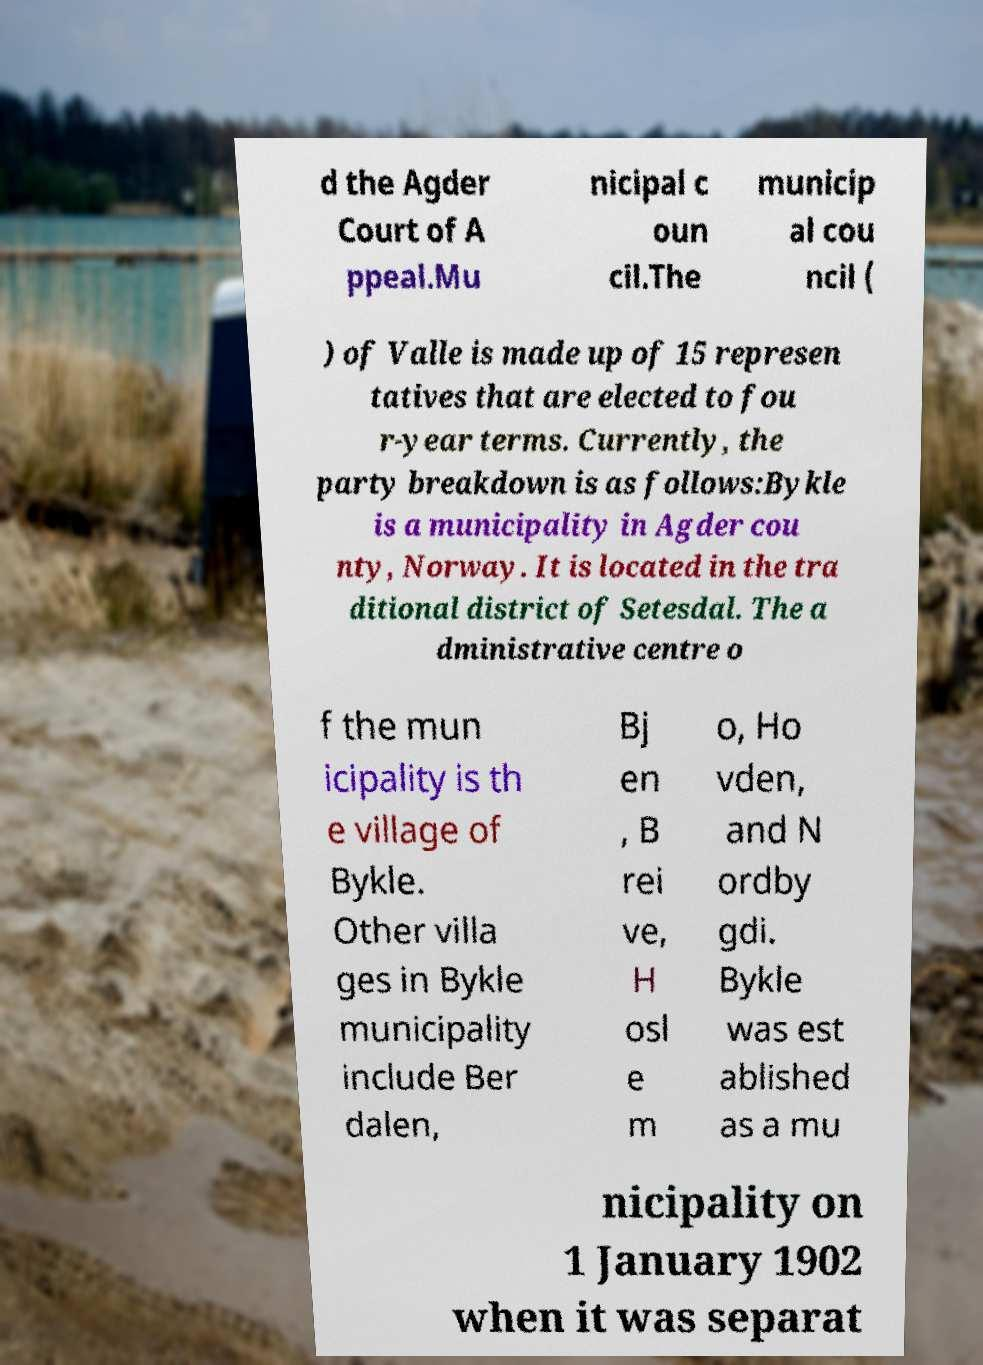For documentation purposes, I need the text within this image transcribed. Could you provide that? d the Agder Court of A ppeal.Mu nicipal c oun cil.The municip al cou ncil ( ) of Valle is made up of 15 represen tatives that are elected to fou r-year terms. Currently, the party breakdown is as follows:Bykle is a municipality in Agder cou nty, Norway. It is located in the tra ditional district of Setesdal. The a dministrative centre o f the mun icipality is th e village of Bykle. Other villa ges in Bykle municipality include Ber dalen, Bj en , B rei ve, H osl e m o, Ho vden, and N ordby gdi. Bykle was est ablished as a mu nicipality on 1 January 1902 when it was separat 